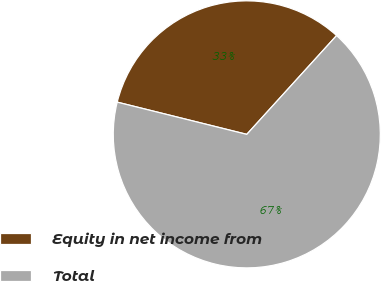Convert chart. <chart><loc_0><loc_0><loc_500><loc_500><pie_chart><fcel>Equity in net income from<fcel>Total<nl><fcel>32.86%<fcel>67.14%<nl></chart> 